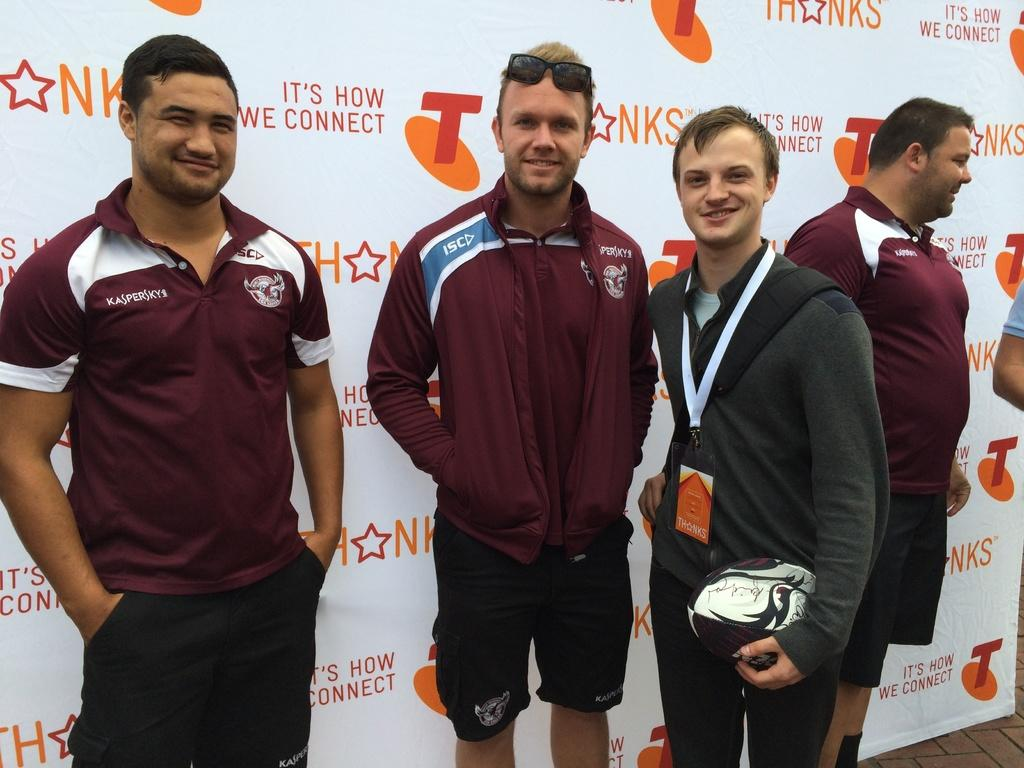<image>
Offer a succinct explanation of the picture presented. IT's HOW WE CONNECT is printed on the banner display in the background. 